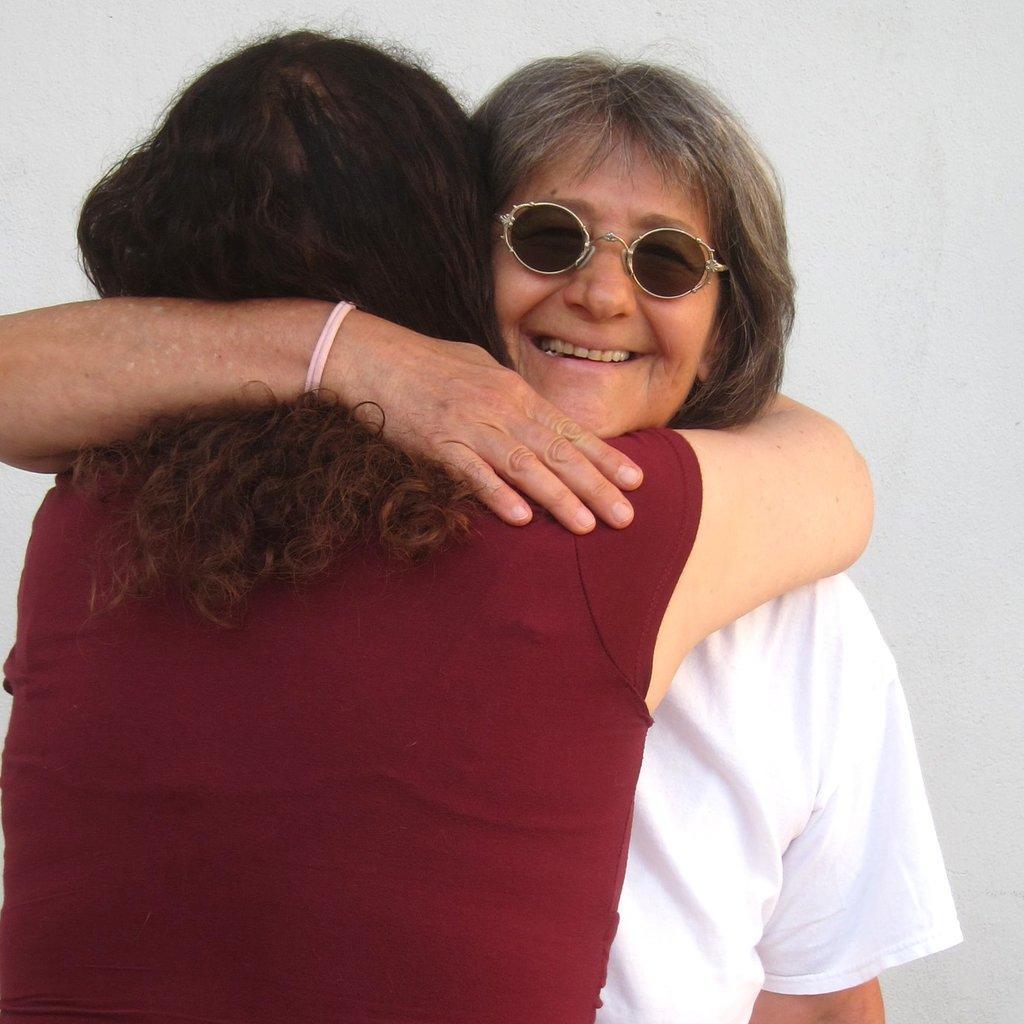How would you summarize this image in a sentence or two? In the foreground of this image, there are two women hugging each other. In the background, there is a wall. 